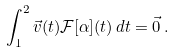<formula> <loc_0><loc_0><loc_500><loc_500>\int _ { 1 } ^ { 2 } \vec { v } ( t ) \mathcal { F } [ \alpha ] ( t ) \, d t = \vec { 0 } \, .</formula> 